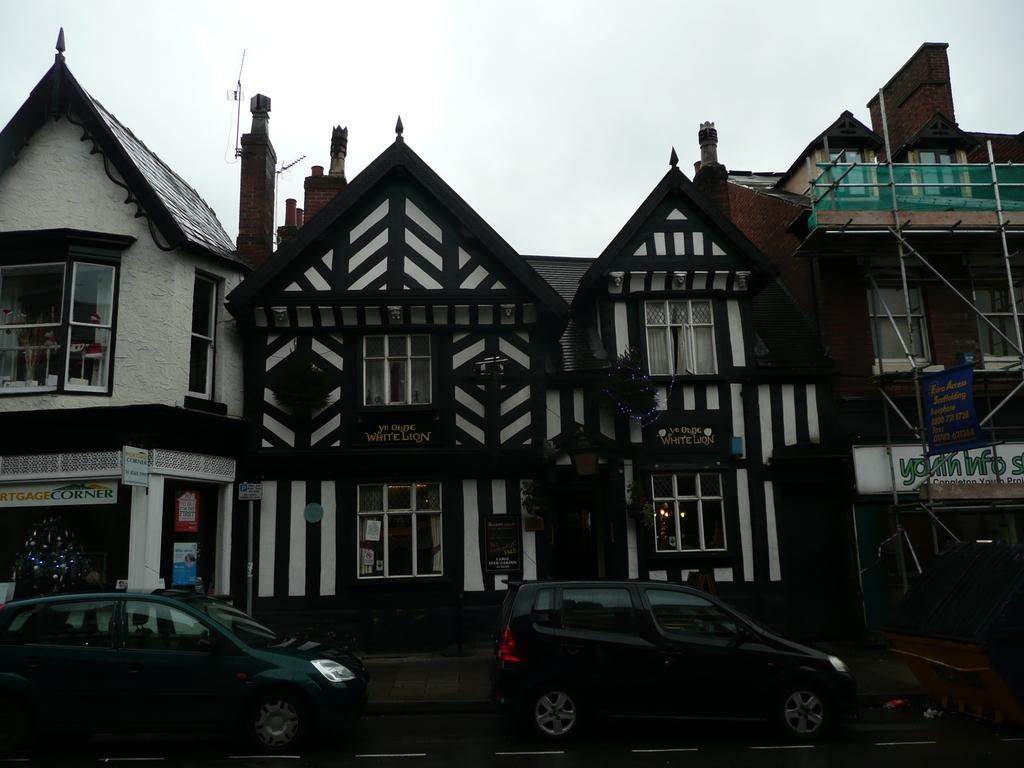What is located at the bottom of the image? There is a road at the bottom of the image. What is happening on the road? Cars are visible on the road. What structures can be seen in the center of the image? There are buildings in the center of the image. What can be seen in the background of the image? The sky is visible in the background of the image. What type of list can be seen hanging on the wall in the image? There is no list present in the image; it features a road, cars, buildings, and the sky. Can you tell me how many teeth are visible in the image? There are no teeth visible in the image. 